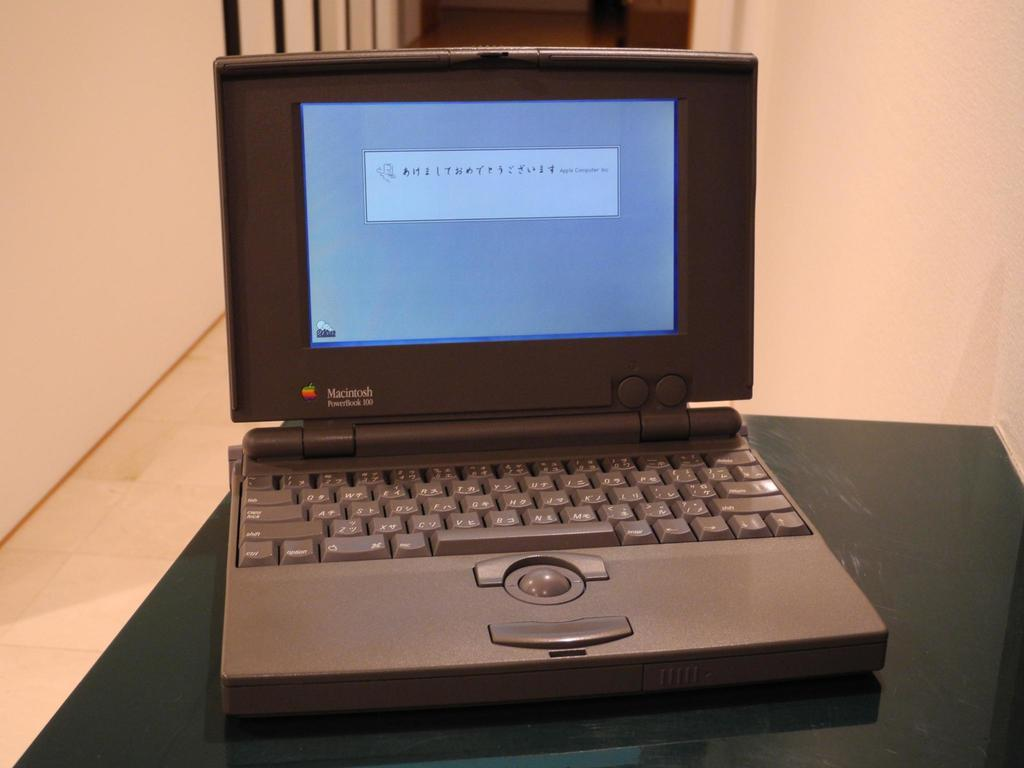<image>
Create a compact narrative representing the image presented. An older laptop with the brand Macintosh written on the monitor. 